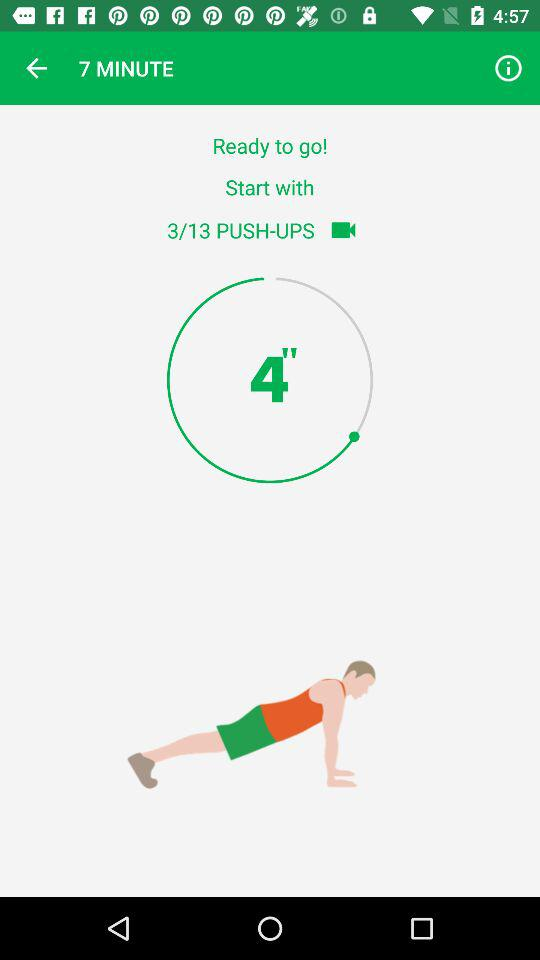How many push-ups in total are there? There are 13 push-ups in total. 